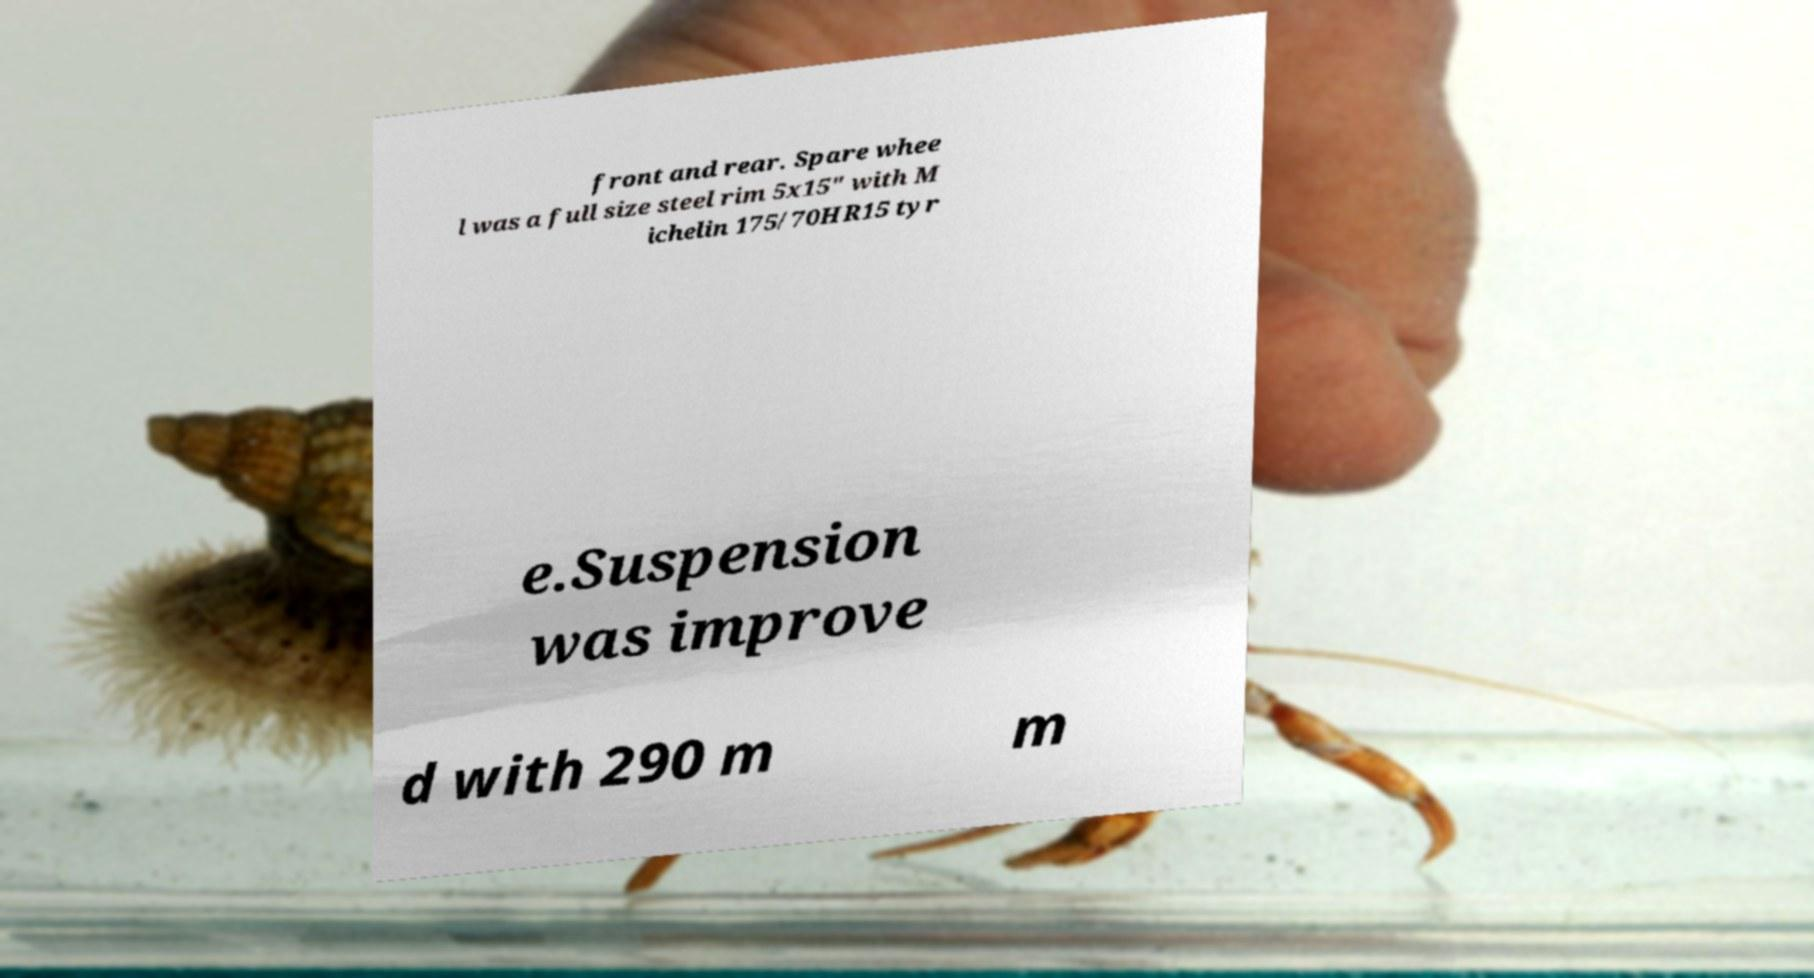I need the written content from this picture converted into text. Can you do that? front and rear. Spare whee l was a full size steel rim 5x15" with M ichelin 175/70HR15 tyr e.Suspension was improve d with 290 m m 